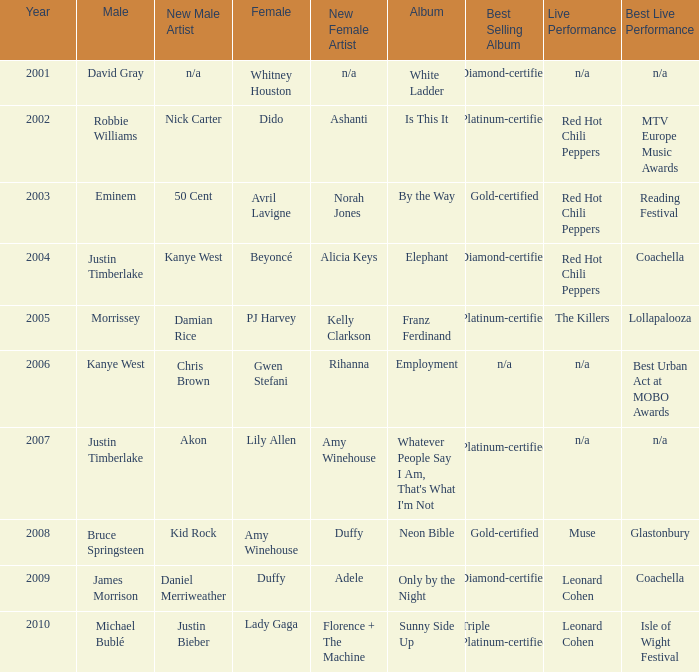Which male is paired with dido in 2004? Robbie Williams. Can you give me this table as a dict? {'header': ['Year', 'Male', 'New Male Artist', 'Female', 'New Female Artist', 'Album', 'Best Selling Album', 'Live Performance', 'Best Live Performance'], 'rows': [['2001', 'David Gray', 'n/a', 'Whitney Houston', 'n/a', 'White Ladder', 'Diamond-certified', 'n/a', 'n/a'], ['2002', 'Robbie Williams', 'Nick Carter', 'Dido', 'Ashanti', 'Is This It', 'Platinum-certified', 'Red Hot Chili Peppers', 'MTV Europe Music Awards'], ['2003', 'Eminem', '50 Cent', 'Avril Lavigne', 'Norah Jones', 'By the Way', 'Gold-certified', 'Red Hot Chili Peppers', 'Reading Festival'], ['2004', 'Justin Timberlake', 'Kanye West', 'Beyoncé', 'Alicia Keys', 'Elephant', 'Diamond-certified', 'Red Hot Chili Peppers', 'Coachella'], ['2005', 'Morrissey', 'Damian Rice', 'PJ Harvey', 'Kelly Clarkson', 'Franz Ferdinand', 'Platinum-certified', 'The Killers', 'Lollapalooza'], ['2006', 'Kanye West', 'Chris Brown', 'Gwen Stefani', 'Rihanna', 'Employment', 'n/a', 'n/a', 'Best Urban Act at MOBO Awards'], ['2007', 'Justin Timberlake', 'Akon', 'Lily Allen', 'Amy Winehouse', "Whatever People Say I Am, That's What I'm Not", 'Platinum-certified ', 'n/a', 'n/a'], ['2008', 'Bruce Springsteen', 'Kid Rock', 'Amy Winehouse', 'Duffy', 'Neon Bible', 'Gold-certified', 'Muse', 'Glastonbury'], ['2009', 'James Morrison', 'Daniel Merriweather', 'Duffy', 'Adele', 'Only by the Night', 'Diamond-certified', 'Leonard Cohen', 'Coachella'], ['2010', 'Michael Bublé', 'Justin Bieber', 'Lady Gaga', 'Florence + The Machine', 'Sunny Side Up', 'Triple Platinum-certified', 'Leonard Cohen', 'Isle of Wight Festival']]} 